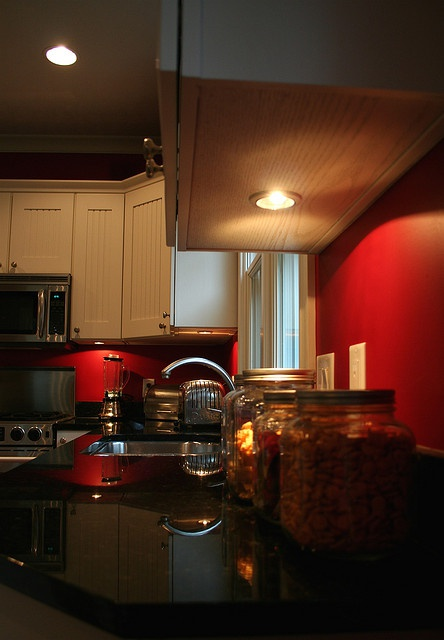Describe the objects in this image and their specific colors. I can see bottle in black, maroon, and brown tones, oven in black, maroon, and gray tones, microwave in black, maroon, and gray tones, bottle in black, maroon, and brown tones, and bottle in black, maroon, and brown tones in this image. 